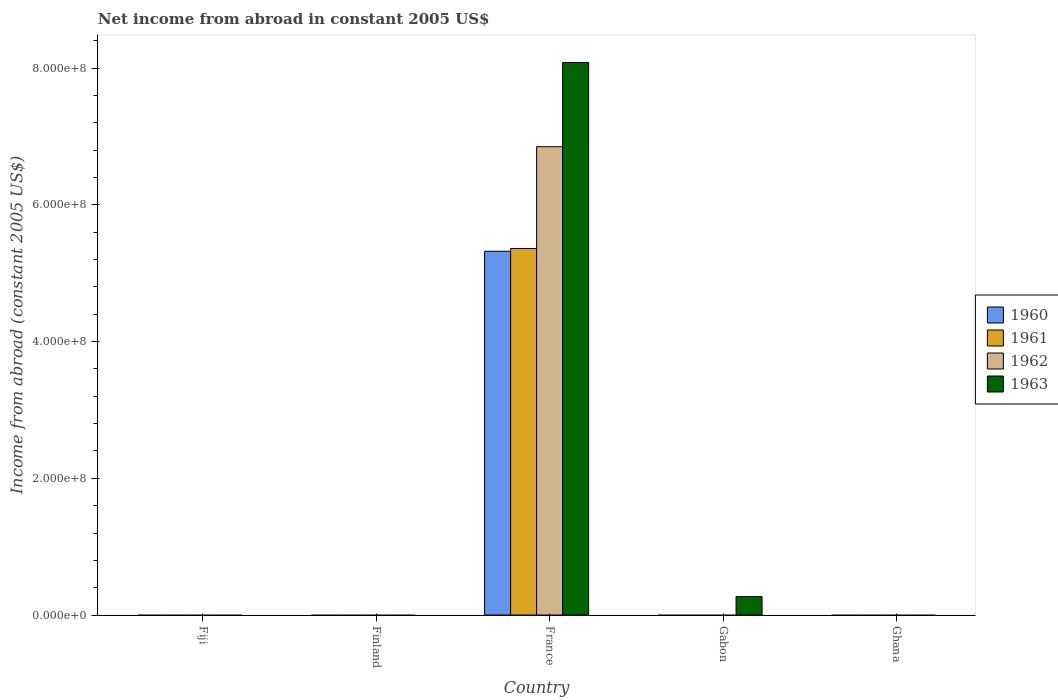How many different coloured bars are there?
Your answer should be very brief. 4. Are the number of bars per tick equal to the number of legend labels?
Give a very brief answer. No. What is the label of the 4th group of bars from the left?
Your answer should be compact. Gabon. What is the net income from abroad in 1963 in Gabon?
Your answer should be very brief. 2.69e+07. Across all countries, what is the maximum net income from abroad in 1960?
Offer a terse response. 5.32e+08. Across all countries, what is the minimum net income from abroad in 1962?
Offer a very short reply. 0. In which country was the net income from abroad in 1960 maximum?
Offer a terse response. France. What is the total net income from abroad in 1960 in the graph?
Offer a very short reply. 5.32e+08. What is the difference between the net income from abroad in 1963 in France and that in Gabon?
Provide a succinct answer. 7.81e+08. What is the difference between the net income from abroad in 1960 in Gabon and the net income from abroad in 1962 in Finland?
Keep it short and to the point. 0. What is the average net income from abroad in 1961 per country?
Keep it short and to the point. 1.07e+08. What is the difference between the net income from abroad of/in 1962 and net income from abroad of/in 1960 in France?
Your answer should be compact. 1.53e+08. In how many countries, is the net income from abroad in 1960 greater than 760000000 US$?
Make the answer very short. 0. What is the ratio of the net income from abroad in 1963 in France to that in Gabon?
Your answer should be very brief. 30.04. What is the difference between the highest and the lowest net income from abroad in 1963?
Offer a terse response. 8.08e+08. How many bars are there?
Provide a succinct answer. 5. What is the difference between two consecutive major ticks on the Y-axis?
Your response must be concise. 2.00e+08. Are the values on the major ticks of Y-axis written in scientific E-notation?
Your response must be concise. Yes. Does the graph contain grids?
Offer a very short reply. No. Where does the legend appear in the graph?
Make the answer very short. Center right. What is the title of the graph?
Give a very brief answer. Net income from abroad in constant 2005 US$. Does "1990" appear as one of the legend labels in the graph?
Give a very brief answer. No. What is the label or title of the Y-axis?
Offer a very short reply. Income from abroad (constant 2005 US$). What is the Income from abroad (constant 2005 US$) in 1960 in Fiji?
Your response must be concise. 0. What is the Income from abroad (constant 2005 US$) of 1961 in Fiji?
Offer a terse response. 0. What is the Income from abroad (constant 2005 US$) in 1961 in Finland?
Offer a very short reply. 0. What is the Income from abroad (constant 2005 US$) in 1960 in France?
Your answer should be compact. 5.32e+08. What is the Income from abroad (constant 2005 US$) in 1961 in France?
Keep it short and to the point. 5.36e+08. What is the Income from abroad (constant 2005 US$) in 1962 in France?
Offer a very short reply. 6.85e+08. What is the Income from abroad (constant 2005 US$) in 1963 in France?
Your answer should be compact. 8.08e+08. What is the Income from abroad (constant 2005 US$) in 1963 in Gabon?
Your response must be concise. 2.69e+07. What is the Income from abroad (constant 2005 US$) in 1960 in Ghana?
Provide a succinct answer. 0. What is the Income from abroad (constant 2005 US$) of 1961 in Ghana?
Your response must be concise. 0. What is the Income from abroad (constant 2005 US$) of 1963 in Ghana?
Give a very brief answer. 0. Across all countries, what is the maximum Income from abroad (constant 2005 US$) of 1960?
Offer a very short reply. 5.32e+08. Across all countries, what is the maximum Income from abroad (constant 2005 US$) of 1961?
Your answer should be compact. 5.36e+08. Across all countries, what is the maximum Income from abroad (constant 2005 US$) of 1962?
Provide a short and direct response. 6.85e+08. Across all countries, what is the maximum Income from abroad (constant 2005 US$) of 1963?
Offer a very short reply. 8.08e+08. What is the total Income from abroad (constant 2005 US$) in 1960 in the graph?
Your response must be concise. 5.32e+08. What is the total Income from abroad (constant 2005 US$) of 1961 in the graph?
Keep it short and to the point. 5.36e+08. What is the total Income from abroad (constant 2005 US$) of 1962 in the graph?
Ensure brevity in your answer.  6.85e+08. What is the total Income from abroad (constant 2005 US$) of 1963 in the graph?
Ensure brevity in your answer.  8.35e+08. What is the difference between the Income from abroad (constant 2005 US$) of 1963 in France and that in Gabon?
Provide a succinct answer. 7.81e+08. What is the difference between the Income from abroad (constant 2005 US$) of 1960 in France and the Income from abroad (constant 2005 US$) of 1963 in Gabon?
Provide a short and direct response. 5.05e+08. What is the difference between the Income from abroad (constant 2005 US$) of 1961 in France and the Income from abroad (constant 2005 US$) of 1963 in Gabon?
Give a very brief answer. 5.09e+08. What is the difference between the Income from abroad (constant 2005 US$) in 1962 in France and the Income from abroad (constant 2005 US$) in 1963 in Gabon?
Offer a terse response. 6.58e+08. What is the average Income from abroad (constant 2005 US$) in 1960 per country?
Your answer should be very brief. 1.06e+08. What is the average Income from abroad (constant 2005 US$) in 1961 per country?
Your response must be concise. 1.07e+08. What is the average Income from abroad (constant 2005 US$) of 1962 per country?
Your answer should be very brief. 1.37e+08. What is the average Income from abroad (constant 2005 US$) of 1963 per country?
Your answer should be compact. 1.67e+08. What is the difference between the Income from abroad (constant 2005 US$) in 1960 and Income from abroad (constant 2005 US$) in 1961 in France?
Offer a terse response. -4.05e+06. What is the difference between the Income from abroad (constant 2005 US$) of 1960 and Income from abroad (constant 2005 US$) of 1962 in France?
Provide a short and direct response. -1.53e+08. What is the difference between the Income from abroad (constant 2005 US$) of 1960 and Income from abroad (constant 2005 US$) of 1963 in France?
Give a very brief answer. -2.76e+08. What is the difference between the Income from abroad (constant 2005 US$) of 1961 and Income from abroad (constant 2005 US$) of 1962 in France?
Your answer should be compact. -1.49e+08. What is the difference between the Income from abroad (constant 2005 US$) of 1961 and Income from abroad (constant 2005 US$) of 1963 in France?
Your response must be concise. -2.72e+08. What is the difference between the Income from abroad (constant 2005 US$) in 1962 and Income from abroad (constant 2005 US$) in 1963 in France?
Make the answer very short. -1.23e+08. What is the ratio of the Income from abroad (constant 2005 US$) in 1963 in France to that in Gabon?
Provide a succinct answer. 30.04. What is the difference between the highest and the lowest Income from abroad (constant 2005 US$) of 1960?
Provide a succinct answer. 5.32e+08. What is the difference between the highest and the lowest Income from abroad (constant 2005 US$) of 1961?
Give a very brief answer. 5.36e+08. What is the difference between the highest and the lowest Income from abroad (constant 2005 US$) in 1962?
Your response must be concise. 6.85e+08. What is the difference between the highest and the lowest Income from abroad (constant 2005 US$) of 1963?
Make the answer very short. 8.08e+08. 